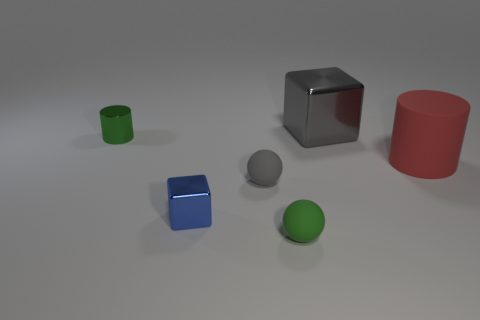Subtract all green balls. How many balls are left? 1 Add 3 green metal cylinders. How many objects exist? 9 Subtract all cylinders. How many objects are left? 4 Subtract 1 cylinders. How many cylinders are left? 1 Subtract all gray cylinders. Subtract all purple blocks. How many cylinders are left? 2 Subtract all red cubes. How many red cylinders are left? 1 Subtract all blue shiny objects. Subtract all large gray metallic blocks. How many objects are left? 4 Add 3 tiny shiny objects. How many tiny shiny objects are left? 5 Add 4 shiny objects. How many shiny objects exist? 7 Subtract 0 green blocks. How many objects are left? 6 